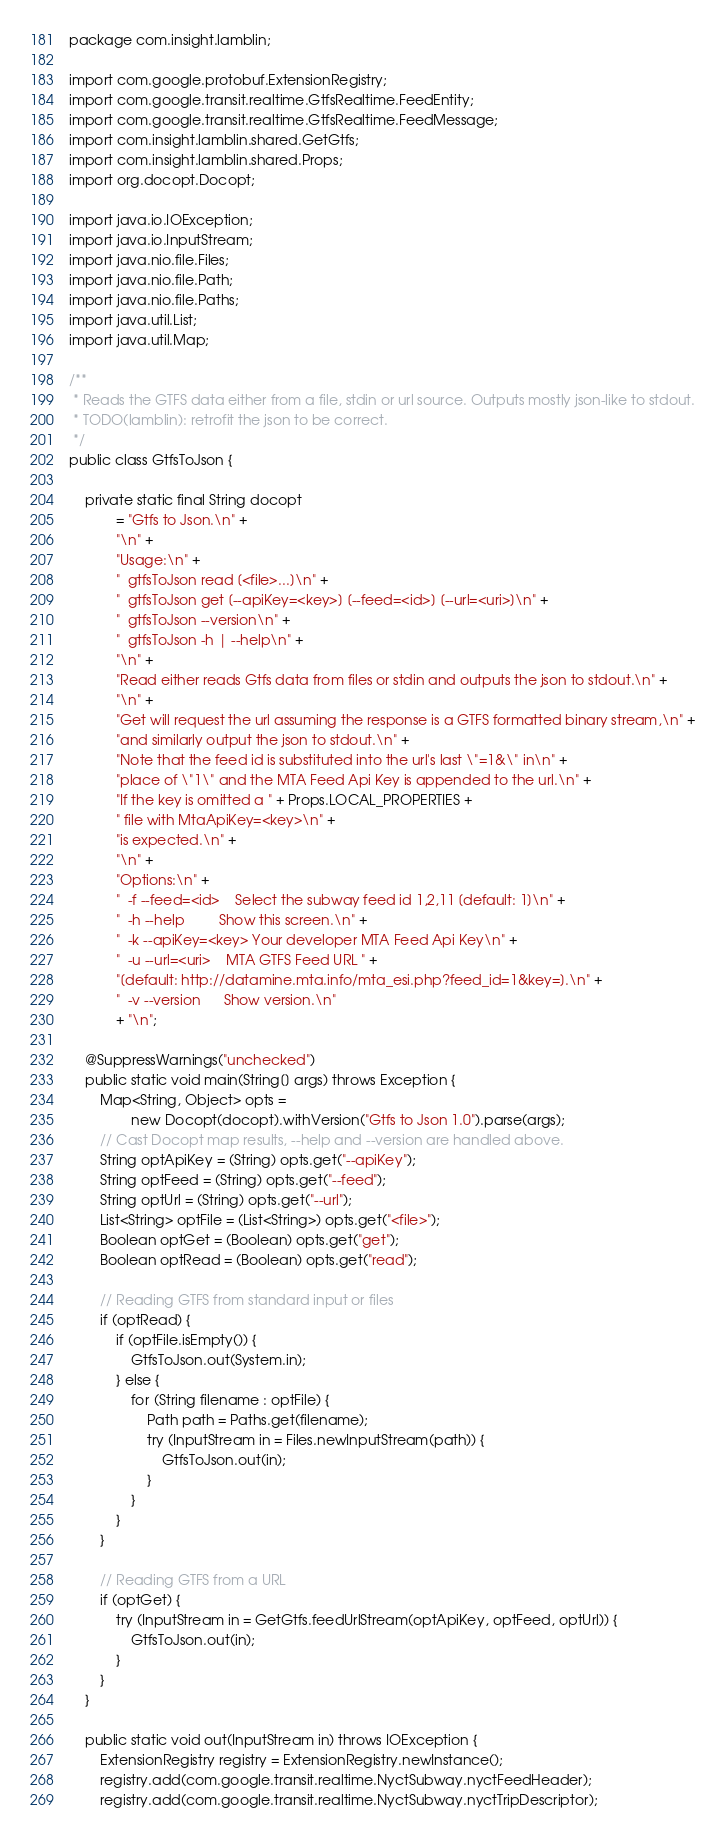Convert code to text. <code><loc_0><loc_0><loc_500><loc_500><_Java_>package com.insight.lamblin;

import com.google.protobuf.ExtensionRegistry;
import com.google.transit.realtime.GtfsRealtime.FeedEntity;
import com.google.transit.realtime.GtfsRealtime.FeedMessage;
import com.insight.lamblin.shared.GetGtfs;
import com.insight.lamblin.shared.Props;
import org.docopt.Docopt;

import java.io.IOException;
import java.io.InputStream;
import java.nio.file.Files;
import java.nio.file.Path;
import java.nio.file.Paths;
import java.util.List;
import java.util.Map;

/**
 * Reads the GTFS data either from a file, stdin or url source. Outputs mostly json-like to stdout.
 * TODO(lamblin): retrofit the json to be correct.
 */
public class GtfsToJson {

    private static final String docopt
            = "Gtfs to Json.\n" +
            "\n" +
            "Usage:\n" +
            "  gtfsToJson read [<file>...]\n" +
            "  gtfsToJson get [--apiKey=<key>] [--feed=<id>] [--url=<uri>]\n" +
            "  gtfsToJson --version\n" +
            "  gtfsToJson -h | --help\n" +
            "\n" +
            "Read either reads Gtfs data from files or stdin and outputs the json to stdout.\n" +
            "\n" +
            "Get will request the url assuming the response is a GTFS formatted binary stream,\n" +
            "and similarly output the json to stdout.\n" +
            "Note that the feed id is substituted into the url's last \"=1&\" in\n" +
            "place of \"1\" and the MTA Feed Api Key is appended to the url.\n" +
            "If the key is omitted a " + Props.LOCAL_PROPERTIES +
            " file with MtaApiKey=<key>\n" +
            "is expected.\n" +
            "\n" +
            "Options:\n" +
            "  -f --feed=<id>    Select the subway feed id 1,2,11 [default: 1]\n" +
            "  -h --help         Show this screen.\n" +
            "  -k --apiKey=<key> Your developer MTA Feed Api Key\n" +
            "  -u --url=<uri>    MTA GTFS Feed URL " +
            "[default: http://datamine.mta.info/mta_esi.php?feed_id=1&key=].\n" +
            "  -v --version      Show version.\n"
            + "\n";

    @SuppressWarnings("unchecked")
    public static void main(String[] args) throws Exception {
        Map<String, Object> opts =
                new Docopt(docopt).withVersion("Gtfs to Json 1.0").parse(args);
        // Cast Docopt map results, --help and --version are handled above.
        String optApiKey = (String) opts.get("--apiKey");
        String optFeed = (String) opts.get("--feed");
        String optUrl = (String) opts.get("--url");
        List<String> optFile = (List<String>) opts.get("<file>");
        Boolean optGet = (Boolean) opts.get("get");
        Boolean optRead = (Boolean) opts.get("read");

        // Reading GTFS from standard input or files
        if (optRead) {
            if (optFile.isEmpty()) {
                GtfsToJson.out(System.in);
            } else {
                for (String filename : optFile) {
                    Path path = Paths.get(filename);
                    try (InputStream in = Files.newInputStream(path)) {
                        GtfsToJson.out(in);
                    }
                }
            }
        }

        // Reading GTFS from a URL
        if (optGet) {
            try (InputStream in = GetGtfs.feedUrlStream(optApiKey, optFeed, optUrl)) {
                GtfsToJson.out(in);
            }
        }
    }

    public static void out(InputStream in) throws IOException {
        ExtensionRegistry registry = ExtensionRegistry.newInstance();
        registry.add(com.google.transit.realtime.NyctSubway.nyctFeedHeader);
        registry.add(com.google.transit.realtime.NyctSubway.nyctTripDescriptor);</code> 